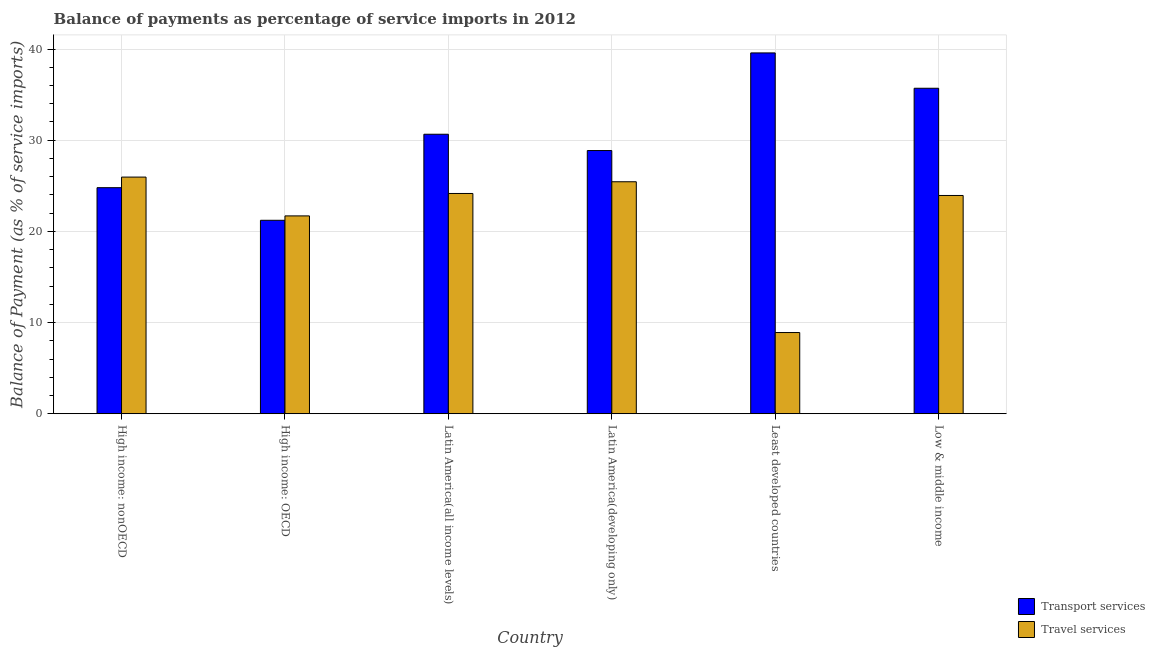How many different coloured bars are there?
Give a very brief answer. 2. How many bars are there on the 4th tick from the left?
Your answer should be compact. 2. What is the label of the 4th group of bars from the left?
Make the answer very short. Latin America(developing only). What is the balance of payments of transport services in High income: nonOECD?
Offer a terse response. 24.79. Across all countries, what is the maximum balance of payments of travel services?
Keep it short and to the point. 25.95. Across all countries, what is the minimum balance of payments of travel services?
Provide a short and direct response. 8.9. In which country was the balance of payments of transport services maximum?
Provide a short and direct response. Least developed countries. In which country was the balance of payments of travel services minimum?
Keep it short and to the point. Least developed countries. What is the total balance of payments of travel services in the graph?
Your response must be concise. 130.09. What is the difference between the balance of payments of transport services in Latin America(developing only) and that in Least developed countries?
Offer a very short reply. -10.71. What is the difference between the balance of payments of travel services in Latin America(developing only) and the balance of payments of transport services in Least developed countries?
Your response must be concise. -14.13. What is the average balance of payments of travel services per country?
Keep it short and to the point. 21.68. What is the difference between the balance of payments of travel services and balance of payments of transport services in High income: OECD?
Provide a short and direct response. 0.48. In how many countries, is the balance of payments of transport services greater than 4 %?
Provide a succinct answer. 6. What is the ratio of the balance of payments of transport services in Latin America(developing only) to that in Low & middle income?
Provide a short and direct response. 0.81. What is the difference between the highest and the second highest balance of payments of travel services?
Keep it short and to the point. 0.51. What is the difference between the highest and the lowest balance of payments of transport services?
Give a very brief answer. 18.36. In how many countries, is the balance of payments of travel services greater than the average balance of payments of travel services taken over all countries?
Offer a terse response. 5. Is the sum of the balance of payments of travel services in High income: nonOECD and Latin America(developing only) greater than the maximum balance of payments of transport services across all countries?
Ensure brevity in your answer.  Yes. What does the 1st bar from the left in High income: OECD represents?
Your response must be concise. Transport services. What does the 1st bar from the right in High income: OECD represents?
Provide a succinct answer. Travel services. Are all the bars in the graph horizontal?
Your response must be concise. No. Are the values on the major ticks of Y-axis written in scientific E-notation?
Offer a terse response. No. Where does the legend appear in the graph?
Provide a short and direct response. Bottom right. How many legend labels are there?
Your answer should be compact. 2. What is the title of the graph?
Ensure brevity in your answer.  Balance of payments as percentage of service imports in 2012. Does "Overweight" appear as one of the legend labels in the graph?
Make the answer very short. No. What is the label or title of the X-axis?
Offer a terse response. Country. What is the label or title of the Y-axis?
Keep it short and to the point. Balance of Payment (as % of service imports). What is the Balance of Payment (as % of service imports) of Transport services in High income: nonOECD?
Offer a very short reply. 24.79. What is the Balance of Payment (as % of service imports) in Travel services in High income: nonOECD?
Offer a terse response. 25.95. What is the Balance of Payment (as % of service imports) of Transport services in High income: OECD?
Offer a terse response. 21.21. What is the Balance of Payment (as % of service imports) of Travel services in High income: OECD?
Offer a terse response. 21.7. What is the Balance of Payment (as % of service imports) in Transport services in Latin America(all income levels)?
Offer a very short reply. 30.65. What is the Balance of Payment (as % of service imports) of Travel services in Latin America(all income levels)?
Provide a short and direct response. 24.16. What is the Balance of Payment (as % of service imports) of Transport services in Latin America(developing only)?
Offer a very short reply. 28.87. What is the Balance of Payment (as % of service imports) of Travel services in Latin America(developing only)?
Give a very brief answer. 25.44. What is the Balance of Payment (as % of service imports) in Transport services in Least developed countries?
Offer a very short reply. 39.57. What is the Balance of Payment (as % of service imports) in Travel services in Least developed countries?
Ensure brevity in your answer.  8.9. What is the Balance of Payment (as % of service imports) in Transport services in Low & middle income?
Offer a terse response. 35.7. What is the Balance of Payment (as % of service imports) in Travel services in Low & middle income?
Give a very brief answer. 23.94. Across all countries, what is the maximum Balance of Payment (as % of service imports) in Transport services?
Provide a succinct answer. 39.57. Across all countries, what is the maximum Balance of Payment (as % of service imports) of Travel services?
Offer a terse response. 25.95. Across all countries, what is the minimum Balance of Payment (as % of service imports) of Transport services?
Your answer should be very brief. 21.21. Across all countries, what is the minimum Balance of Payment (as % of service imports) of Travel services?
Keep it short and to the point. 8.9. What is the total Balance of Payment (as % of service imports) in Transport services in the graph?
Give a very brief answer. 180.79. What is the total Balance of Payment (as % of service imports) in Travel services in the graph?
Ensure brevity in your answer.  130.09. What is the difference between the Balance of Payment (as % of service imports) of Transport services in High income: nonOECD and that in High income: OECD?
Give a very brief answer. 3.58. What is the difference between the Balance of Payment (as % of service imports) in Travel services in High income: nonOECD and that in High income: OECD?
Offer a terse response. 4.26. What is the difference between the Balance of Payment (as % of service imports) of Transport services in High income: nonOECD and that in Latin America(all income levels)?
Your answer should be compact. -5.86. What is the difference between the Balance of Payment (as % of service imports) in Travel services in High income: nonOECD and that in Latin America(all income levels)?
Your response must be concise. 1.8. What is the difference between the Balance of Payment (as % of service imports) in Transport services in High income: nonOECD and that in Latin America(developing only)?
Keep it short and to the point. -4.07. What is the difference between the Balance of Payment (as % of service imports) of Travel services in High income: nonOECD and that in Latin America(developing only)?
Offer a terse response. 0.51. What is the difference between the Balance of Payment (as % of service imports) in Transport services in High income: nonOECD and that in Least developed countries?
Your response must be concise. -14.78. What is the difference between the Balance of Payment (as % of service imports) of Travel services in High income: nonOECD and that in Least developed countries?
Your answer should be compact. 17.05. What is the difference between the Balance of Payment (as % of service imports) in Transport services in High income: nonOECD and that in Low & middle income?
Your answer should be very brief. -10.9. What is the difference between the Balance of Payment (as % of service imports) in Travel services in High income: nonOECD and that in Low & middle income?
Offer a very short reply. 2.02. What is the difference between the Balance of Payment (as % of service imports) in Transport services in High income: OECD and that in Latin America(all income levels)?
Keep it short and to the point. -9.44. What is the difference between the Balance of Payment (as % of service imports) of Travel services in High income: OECD and that in Latin America(all income levels)?
Your answer should be compact. -2.46. What is the difference between the Balance of Payment (as % of service imports) in Transport services in High income: OECD and that in Latin America(developing only)?
Offer a terse response. -7.65. What is the difference between the Balance of Payment (as % of service imports) of Travel services in High income: OECD and that in Latin America(developing only)?
Give a very brief answer. -3.75. What is the difference between the Balance of Payment (as % of service imports) of Transport services in High income: OECD and that in Least developed countries?
Ensure brevity in your answer.  -18.36. What is the difference between the Balance of Payment (as % of service imports) in Travel services in High income: OECD and that in Least developed countries?
Make the answer very short. 12.79. What is the difference between the Balance of Payment (as % of service imports) in Transport services in High income: OECD and that in Low & middle income?
Keep it short and to the point. -14.48. What is the difference between the Balance of Payment (as % of service imports) of Travel services in High income: OECD and that in Low & middle income?
Keep it short and to the point. -2.24. What is the difference between the Balance of Payment (as % of service imports) in Transport services in Latin America(all income levels) and that in Latin America(developing only)?
Your answer should be compact. 1.79. What is the difference between the Balance of Payment (as % of service imports) of Travel services in Latin America(all income levels) and that in Latin America(developing only)?
Offer a terse response. -1.29. What is the difference between the Balance of Payment (as % of service imports) in Transport services in Latin America(all income levels) and that in Least developed countries?
Your response must be concise. -8.92. What is the difference between the Balance of Payment (as % of service imports) in Travel services in Latin America(all income levels) and that in Least developed countries?
Keep it short and to the point. 15.25. What is the difference between the Balance of Payment (as % of service imports) of Transport services in Latin America(all income levels) and that in Low & middle income?
Keep it short and to the point. -5.04. What is the difference between the Balance of Payment (as % of service imports) of Travel services in Latin America(all income levels) and that in Low & middle income?
Give a very brief answer. 0.22. What is the difference between the Balance of Payment (as % of service imports) in Transport services in Latin America(developing only) and that in Least developed countries?
Your answer should be compact. -10.71. What is the difference between the Balance of Payment (as % of service imports) in Travel services in Latin America(developing only) and that in Least developed countries?
Your response must be concise. 16.54. What is the difference between the Balance of Payment (as % of service imports) of Transport services in Latin America(developing only) and that in Low & middle income?
Your answer should be compact. -6.83. What is the difference between the Balance of Payment (as % of service imports) of Travel services in Latin America(developing only) and that in Low & middle income?
Keep it short and to the point. 1.51. What is the difference between the Balance of Payment (as % of service imports) in Transport services in Least developed countries and that in Low & middle income?
Your answer should be compact. 3.88. What is the difference between the Balance of Payment (as % of service imports) of Travel services in Least developed countries and that in Low & middle income?
Your answer should be very brief. -15.03. What is the difference between the Balance of Payment (as % of service imports) of Transport services in High income: nonOECD and the Balance of Payment (as % of service imports) of Travel services in High income: OECD?
Offer a very short reply. 3.09. What is the difference between the Balance of Payment (as % of service imports) in Transport services in High income: nonOECD and the Balance of Payment (as % of service imports) in Travel services in Latin America(all income levels)?
Your response must be concise. 0.63. What is the difference between the Balance of Payment (as % of service imports) in Transport services in High income: nonOECD and the Balance of Payment (as % of service imports) in Travel services in Latin America(developing only)?
Ensure brevity in your answer.  -0.65. What is the difference between the Balance of Payment (as % of service imports) in Transport services in High income: nonOECD and the Balance of Payment (as % of service imports) in Travel services in Least developed countries?
Provide a short and direct response. 15.89. What is the difference between the Balance of Payment (as % of service imports) in Transport services in High income: nonOECD and the Balance of Payment (as % of service imports) in Travel services in Low & middle income?
Make the answer very short. 0.85. What is the difference between the Balance of Payment (as % of service imports) of Transport services in High income: OECD and the Balance of Payment (as % of service imports) of Travel services in Latin America(all income levels)?
Keep it short and to the point. -2.94. What is the difference between the Balance of Payment (as % of service imports) of Transport services in High income: OECD and the Balance of Payment (as % of service imports) of Travel services in Latin America(developing only)?
Provide a short and direct response. -4.23. What is the difference between the Balance of Payment (as % of service imports) of Transport services in High income: OECD and the Balance of Payment (as % of service imports) of Travel services in Least developed countries?
Your response must be concise. 12.31. What is the difference between the Balance of Payment (as % of service imports) of Transport services in High income: OECD and the Balance of Payment (as % of service imports) of Travel services in Low & middle income?
Make the answer very short. -2.72. What is the difference between the Balance of Payment (as % of service imports) of Transport services in Latin America(all income levels) and the Balance of Payment (as % of service imports) of Travel services in Latin America(developing only)?
Give a very brief answer. 5.21. What is the difference between the Balance of Payment (as % of service imports) of Transport services in Latin America(all income levels) and the Balance of Payment (as % of service imports) of Travel services in Least developed countries?
Keep it short and to the point. 21.75. What is the difference between the Balance of Payment (as % of service imports) in Transport services in Latin America(all income levels) and the Balance of Payment (as % of service imports) in Travel services in Low & middle income?
Provide a succinct answer. 6.72. What is the difference between the Balance of Payment (as % of service imports) in Transport services in Latin America(developing only) and the Balance of Payment (as % of service imports) in Travel services in Least developed countries?
Give a very brief answer. 19.96. What is the difference between the Balance of Payment (as % of service imports) of Transport services in Latin America(developing only) and the Balance of Payment (as % of service imports) of Travel services in Low & middle income?
Provide a succinct answer. 4.93. What is the difference between the Balance of Payment (as % of service imports) in Transport services in Least developed countries and the Balance of Payment (as % of service imports) in Travel services in Low & middle income?
Provide a short and direct response. 15.63. What is the average Balance of Payment (as % of service imports) in Transport services per country?
Offer a very short reply. 30.13. What is the average Balance of Payment (as % of service imports) of Travel services per country?
Give a very brief answer. 21.68. What is the difference between the Balance of Payment (as % of service imports) in Transport services and Balance of Payment (as % of service imports) in Travel services in High income: nonOECD?
Provide a succinct answer. -1.16. What is the difference between the Balance of Payment (as % of service imports) of Transport services and Balance of Payment (as % of service imports) of Travel services in High income: OECD?
Provide a short and direct response. -0.48. What is the difference between the Balance of Payment (as % of service imports) in Transport services and Balance of Payment (as % of service imports) in Travel services in Latin America(all income levels)?
Ensure brevity in your answer.  6.5. What is the difference between the Balance of Payment (as % of service imports) in Transport services and Balance of Payment (as % of service imports) in Travel services in Latin America(developing only)?
Your response must be concise. 3.42. What is the difference between the Balance of Payment (as % of service imports) of Transport services and Balance of Payment (as % of service imports) of Travel services in Least developed countries?
Offer a very short reply. 30.67. What is the difference between the Balance of Payment (as % of service imports) in Transport services and Balance of Payment (as % of service imports) in Travel services in Low & middle income?
Ensure brevity in your answer.  11.76. What is the ratio of the Balance of Payment (as % of service imports) of Transport services in High income: nonOECD to that in High income: OECD?
Make the answer very short. 1.17. What is the ratio of the Balance of Payment (as % of service imports) of Travel services in High income: nonOECD to that in High income: OECD?
Provide a succinct answer. 1.2. What is the ratio of the Balance of Payment (as % of service imports) of Transport services in High income: nonOECD to that in Latin America(all income levels)?
Your answer should be compact. 0.81. What is the ratio of the Balance of Payment (as % of service imports) in Travel services in High income: nonOECD to that in Latin America(all income levels)?
Give a very brief answer. 1.07. What is the ratio of the Balance of Payment (as % of service imports) in Transport services in High income: nonOECD to that in Latin America(developing only)?
Offer a terse response. 0.86. What is the ratio of the Balance of Payment (as % of service imports) of Travel services in High income: nonOECD to that in Latin America(developing only)?
Keep it short and to the point. 1.02. What is the ratio of the Balance of Payment (as % of service imports) in Transport services in High income: nonOECD to that in Least developed countries?
Your answer should be compact. 0.63. What is the ratio of the Balance of Payment (as % of service imports) in Travel services in High income: nonOECD to that in Least developed countries?
Provide a short and direct response. 2.91. What is the ratio of the Balance of Payment (as % of service imports) of Transport services in High income: nonOECD to that in Low & middle income?
Give a very brief answer. 0.69. What is the ratio of the Balance of Payment (as % of service imports) in Travel services in High income: nonOECD to that in Low & middle income?
Offer a very short reply. 1.08. What is the ratio of the Balance of Payment (as % of service imports) in Transport services in High income: OECD to that in Latin America(all income levels)?
Your answer should be compact. 0.69. What is the ratio of the Balance of Payment (as % of service imports) of Travel services in High income: OECD to that in Latin America(all income levels)?
Offer a very short reply. 0.9. What is the ratio of the Balance of Payment (as % of service imports) in Transport services in High income: OECD to that in Latin America(developing only)?
Ensure brevity in your answer.  0.73. What is the ratio of the Balance of Payment (as % of service imports) in Travel services in High income: OECD to that in Latin America(developing only)?
Offer a terse response. 0.85. What is the ratio of the Balance of Payment (as % of service imports) of Transport services in High income: OECD to that in Least developed countries?
Provide a short and direct response. 0.54. What is the ratio of the Balance of Payment (as % of service imports) in Travel services in High income: OECD to that in Least developed countries?
Ensure brevity in your answer.  2.44. What is the ratio of the Balance of Payment (as % of service imports) of Transport services in High income: OECD to that in Low & middle income?
Your answer should be very brief. 0.59. What is the ratio of the Balance of Payment (as % of service imports) in Travel services in High income: OECD to that in Low & middle income?
Offer a terse response. 0.91. What is the ratio of the Balance of Payment (as % of service imports) in Transport services in Latin America(all income levels) to that in Latin America(developing only)?
Your response must be concise. 1.06. What is the ratio of the Balance of Payment (as % of service imports) in Travel services in Latin America(all income levels) to that in Latin America(developing only)?
Make the answer very short. 0.95. What is the ratio of the Balance of Payment (as % of service imports) of Transport services in Latin America(all income levels) to that in Least developed countries?
Offer a very short reply. 0.77. What is the ratio of the Balance of Payment (as % of service imports) of Travel services in Latin America(all income levels) to that in Least developed countries?
Provide a succinct answer. 2.71. What is the ratio of the Balance of Payment (as % of service imports) of Transport services in Latin America(all income levels) to that in Low & middle income?
Give a very brief answer. 0.86. What is the ratio of the Balance of Payment (as % of service imports) in Travel services in Latin America(all income levels) to that in Low & middle income?
Make the answer very short. 1.01. What is the ratio of the Balance of Payment (as % of service imports) in Transport services in Latin America(developing only) to that in Least developed countries?
Provide a succinct answer. 0.73. What is the ratio of the Balance of Payment (as % of service imports) of Travel services in Latin America(developing only) to that in Least developed countries?
Give a very brief answer. 2.86. What is the ratio of the Balance of Payment (as % of service imports) in Transport services in Latin America(developing only) to that in Low & middle income?
Make the answer very short. 0.81. What is the ratio of the Balance of Payment (as % of service imports) in Travel services in Latin America(developing only) to that in Low & middle income?
Give a very brief answer. 1.06. What is the ratio of the Balance of Payment (as % of service imports) in Transport services in Least developed countries to that in Low & middle income?
Make the answer very short. 1.11. What is the ratio of the Balance of Payment (as % of service imports) in Travel services in Least developed countries to that in Low & middle income?
Your answer should be compact. 0.37. What is the difference between the highest and the second highest Balance of Payment (as % of service imports) of Transport services?
Provide a short and direct response. 3.88. What is the difference between the highest and the second highest Balance of Payment (as % of service imports) in Travel services?
Offer a very short reply. 0.51. What is the difference between the highest and the lowest Balance of Payment (as % of service imports) in Transport services?
Your response must be concise. 18.36. What is the difference between the highest and the lowest Balance of Payment (as % of service imports) of Travel services?
Make the answer very short. 17.05. 